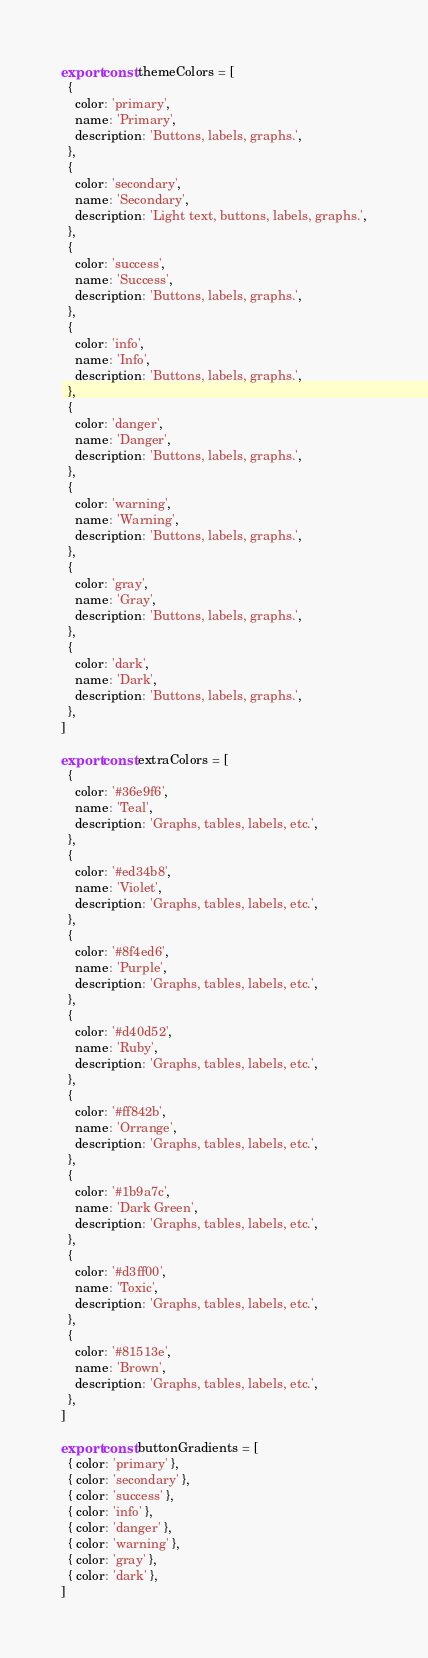<code> <loc_0><loc_0><loc_500><loc_500><_JavaScript_>export const themeColors = [
  {
    color: 'primary',
    name: 'Primary',
    description: 'Buttons, labels, graphs.',
  },
  {
    color: 'secondary',
    name: 'Secondary',
    description: 'Light text, buttons, labels, graphs.',
  },
  {
    color: 'success',
    name: 'Success',
    description: 'Buttons, labels, graphs.',
  },
  {
    color: 'info',
    name: 'Info',
    description: 'Buttons, labels, graphs.',
  },
  {
    color: 'danger',
    name: 'Danger',
    description: 'Buttons, labels, graphs.',
  },
  {
    color: 'warning',
    name: 'Warning',
    description: 'Buttons, labels, graphs.',
  },
  {
    color: 'gray',
    name: 'Gray',
    description: 'Buttons, labels, graphs.',
  },
  {
    color: 'dark',
    name: 'Dark',
    description: 'Buttons, labels, graphs.',
  },
]

export const extraColors = [
  {
    color: '#36e9f6',
    name: 'Teal',
    description: 'Graphs, tables, labels, etc.',
  },
  {
    color: '#ed34b8',
    name: 'Violet',
    description: 'Graphs, tables, labels, etc.',
  },
  {
    color: '#8f4ed6',
    name: 'Purple',
    description: 'Graphs, tables, labels, etc.',
  },
  {
    color: '#d40d52',
    name: 'Ruby',
    description: 'Graphs, tables, labels, etc.',
  },
  {
    color: '#ff842b',
    name: 'Orrange',
    description: 'Graphs, tables, labels, etc.',
  },
  {
    color: '#1b9a7c',
    name: 'Dark Green',
    description: 'Graphs, tables, labels, etc.',
  },
  {
    color: '#d3ff00',
    name: 'Toxic',
    description: 'Graphs, tables, labels, etc.',
  },
  {
    color: '#81513e',
    name: 'Brown',
    description: 'Graphs, tables, labels, etc.',
  },
]

export const buttonGradients = [
  { color: 'primary' },
  { color: 'secondary' },
  { color: 'success' },
  { color: 'info' },
  { color: 'danger' },
  { color: 'warning' },
  { color: 'gray' },
  { color: 'dark' },
]
</code> 